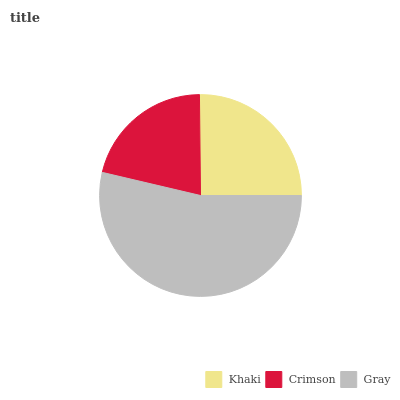Is Crimson the minimum?
Answer yes or no. Yes. Is Gray the maximum?
Answer yes or no. Yes. Is Gray the minimum?
Answer yes or no. No. Is Crimson the maximum?
Answer yes or no. No. Is Gray greater than Crimson?
Answer yes or no. Yes. Is Crimson less than Gray?
Answer yes or no. Yes. Is Crimson greater than Gray?
Answer yes or no. No. Is Gray less than Crimson?
Answer yes or no. No. Is Khaki the high median?
Answer yes or no. Yes. Is Khaki the low median?
Answer yes or no. Yes. Is Crimson the high median?
Answer yes or no. No. Is Gray the low median?
Answer yes or no. No. 